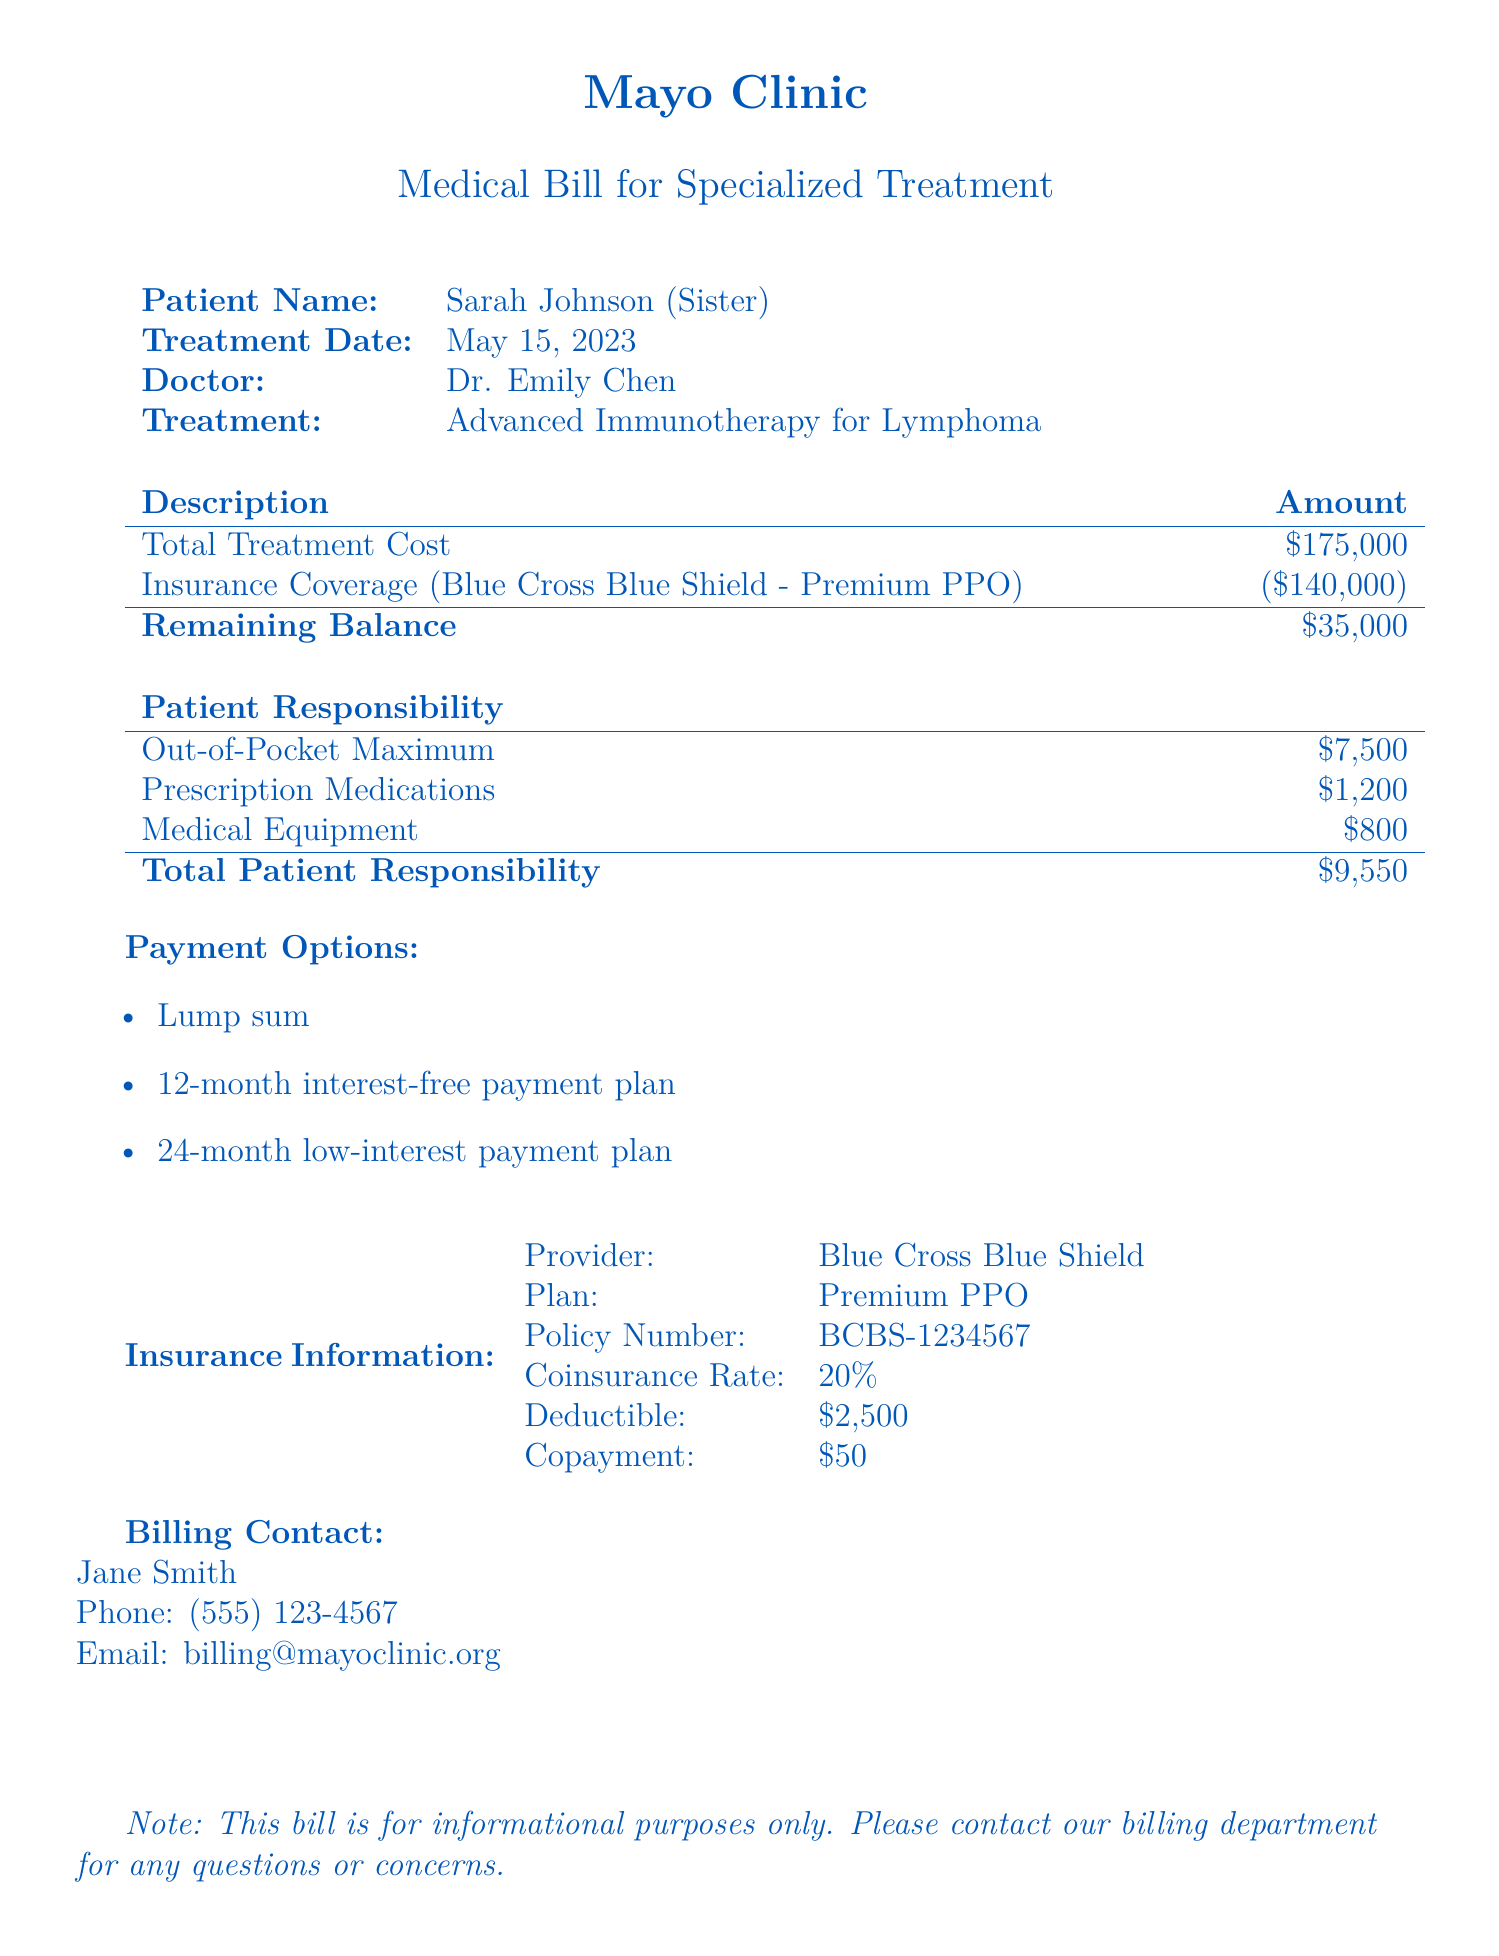What is the patient's name? The patient's name is presented at the top of the document under "Patient Name."
Answer: Sarah Johnson What is the total treatment cost? The total treatment cost is indicated in the "Description" section of the billing, showing the overall amount before insurance.
Answer: $175,000 What is the insurance provider? The insurance provider is specified in the "Insurance Information" section.
Answer: Blue Cross Blue Shield What is the remaining balance after insurance coverage? The remaining balance is calculated by deducting the insurance coverage from the total treatment cost, shown in the "Remaining Balance."
Answer: $35,000 What is the out-of-pocket maximum for the patient? The out-of-pocket maximum is listed under "Patient Responsibility" and indicates the maximum amount the patient will pay out-of-pocket.
Answer: $7,500 What payment options are available? The payment options are listed at the end of the document.
Answer: Lump sum, 12-month interest-free payment plan, 24-month low-interest payment plan What is the coinsurance rate of the insurance plan? The coinsurance rate is specified in the "Insurance Information" section.
Answer: 20% How much did the patient spend on prescription medications? The cost incurred by the patient for prescription medications is shown under "Patient Responsibility."
Answer: $1,200 What is the deductible for the insurance plan? The deductible amount is mentioned in the "Insurance Information" section.
Answer: $2,500 